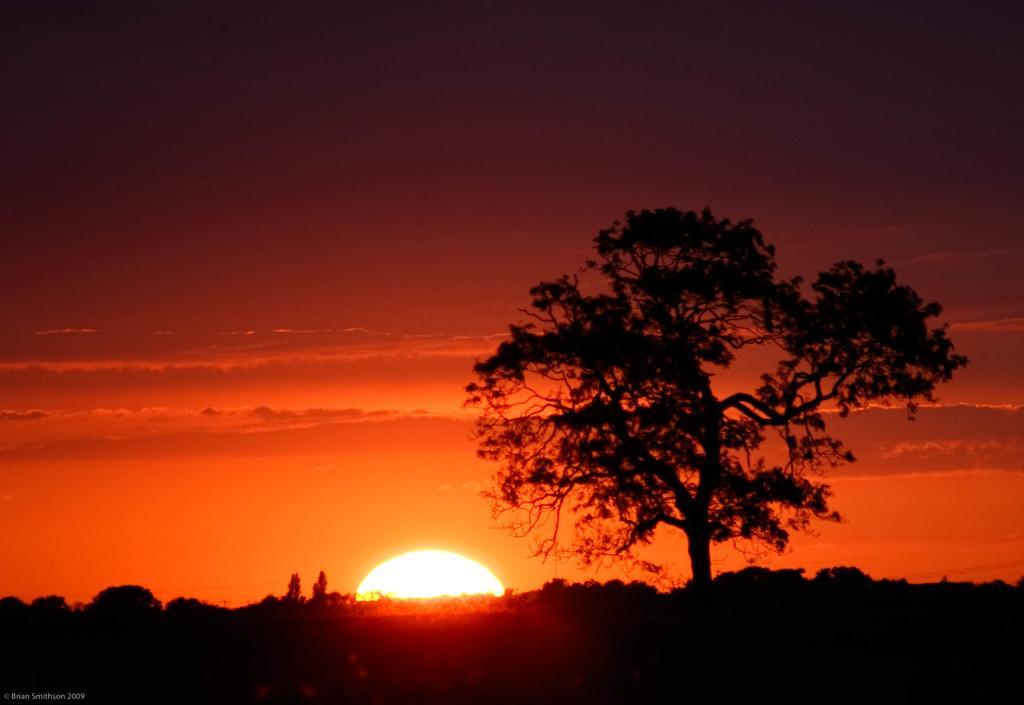Please provide a concise description of this image. On the right side of the image we can see a tree. At the bottom of the image we can see the trees and sun rise is present in the sky. In the background of the image we can see the clouds are present in the sky. In the bottom left corner we can see the text. 